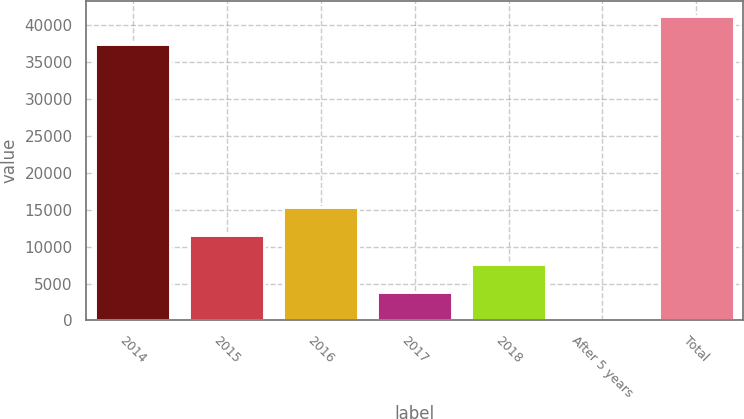Convert chart to OTSL. <chart><loc_0><loc_0><loc_500><loc_500><bar_chart><fcel>2014<fcel>2015<fcel>2016<fcel>2017<fcel>2018<fcel>After 5 years<fcel>Total<nl><fcel>37394<fcel>11535.9<fcel>15377.2<fcel>3853.3<fcel>7694.6<fcel>12<fcel>41235.3<nl></chart> 